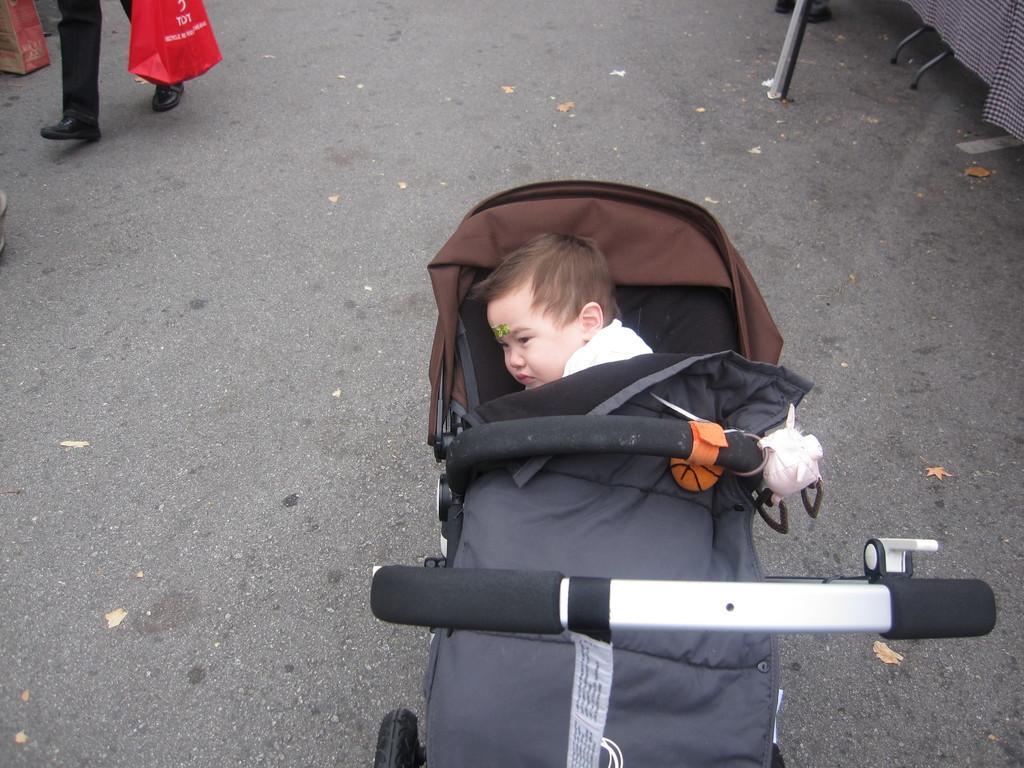In one or two sentences, can you explain what this image depicts? There is a baby in a stroller wearing a white dress. we can see legs of a person at the left holding a red bag. 